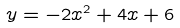Convert formula to latex. <formula><loc_0><loc_0><loc_500><loc_500>y = - 2 x ^ { 2 } + 4 x + 6</formula> 